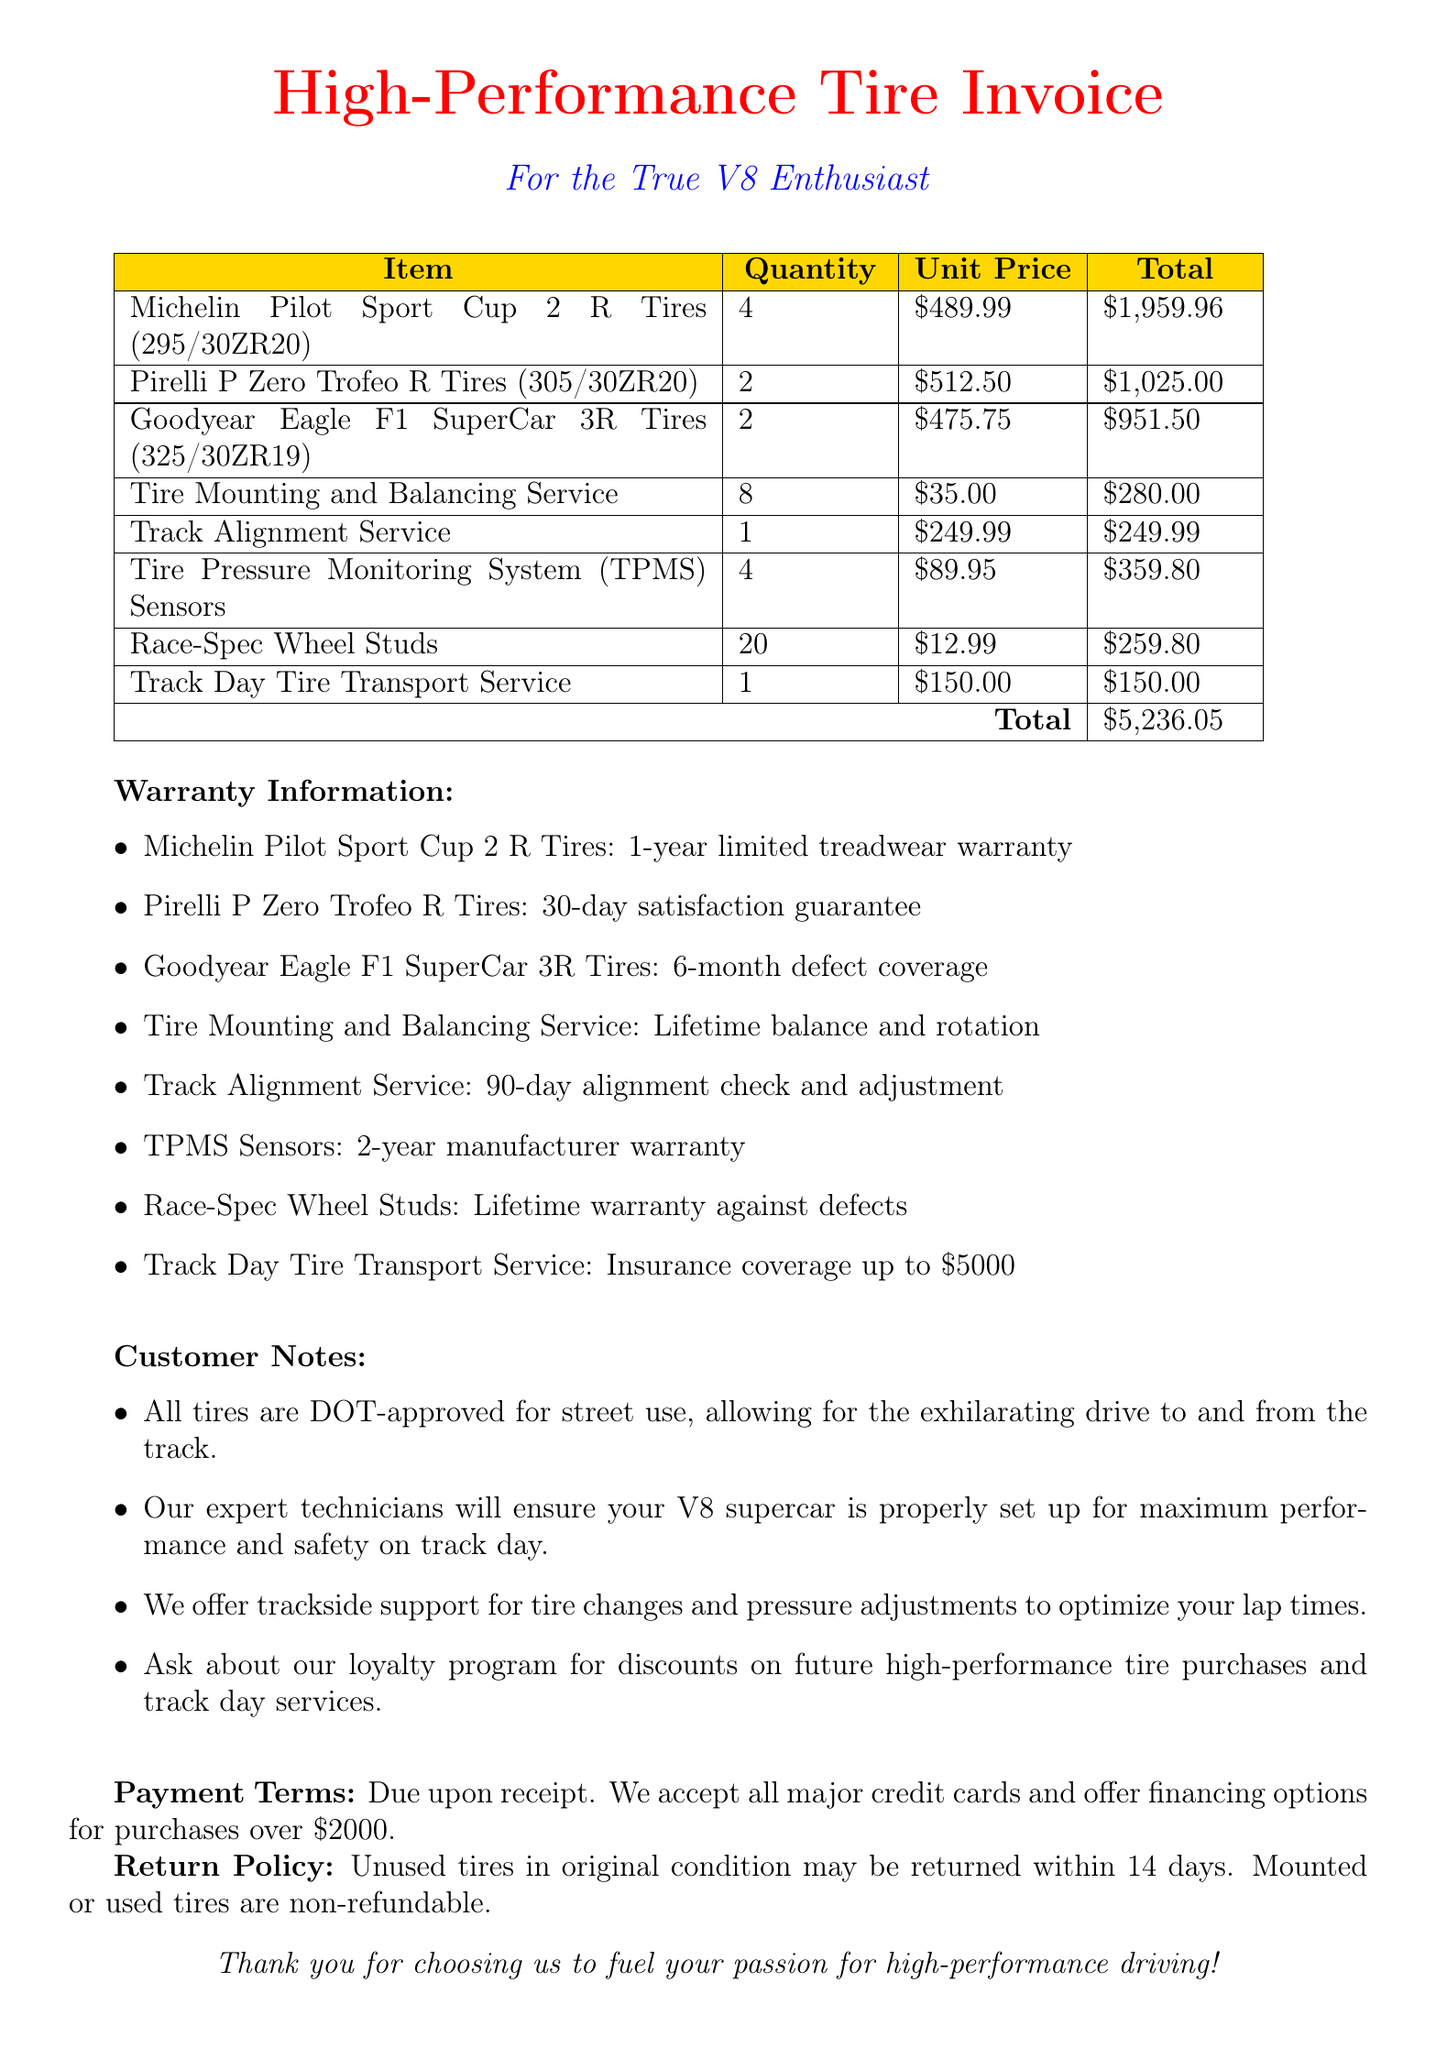What is the total amount for the invoice? The total amount is listed at the end of the invoice after summing up all individual items.
Answer: $5,236.05 How many Michelin Pilot Sport Cup 2 R Tires were purchased? The quantity is specified alongside each item in the invoice table for the Michelin Pilot Sport Cup 2 R Tires.
Answer: 4 What warranty is offered for the Pirelli P Zero Trofeo R Tires? The warranty details for each tire are provided in the warranty information section of the document.
Answer: 30-day satisfaction guarantee What service is covered by a lifetime warranty against defects? This refers to one of the services or products that include a lifetime warranty mentioned in the warranty information.
Answer: Race-Spec Wheel Studs What is the quantity of Tire Pressure Monitoring System (TPMS) Sensors ordered? The quantity is specified in the invoice table for the TPMS Sensors.
Answer: 4 What is the unit price for the Track Alignment Service? The unit price is clearly stated in the invoice table under the unit price column for the Track Alignment Service.
Answer: $249.99 What payment options are mentioned? The invoice includes a section that describes payment terms and accepted methods.
Answer: Major credit cards and financing options What is the return policy for unused tires? The return policy is outlined towards the end of the document, specifically for unused tires.
Answer: Unused tires in original condition may be returned within 14 days 